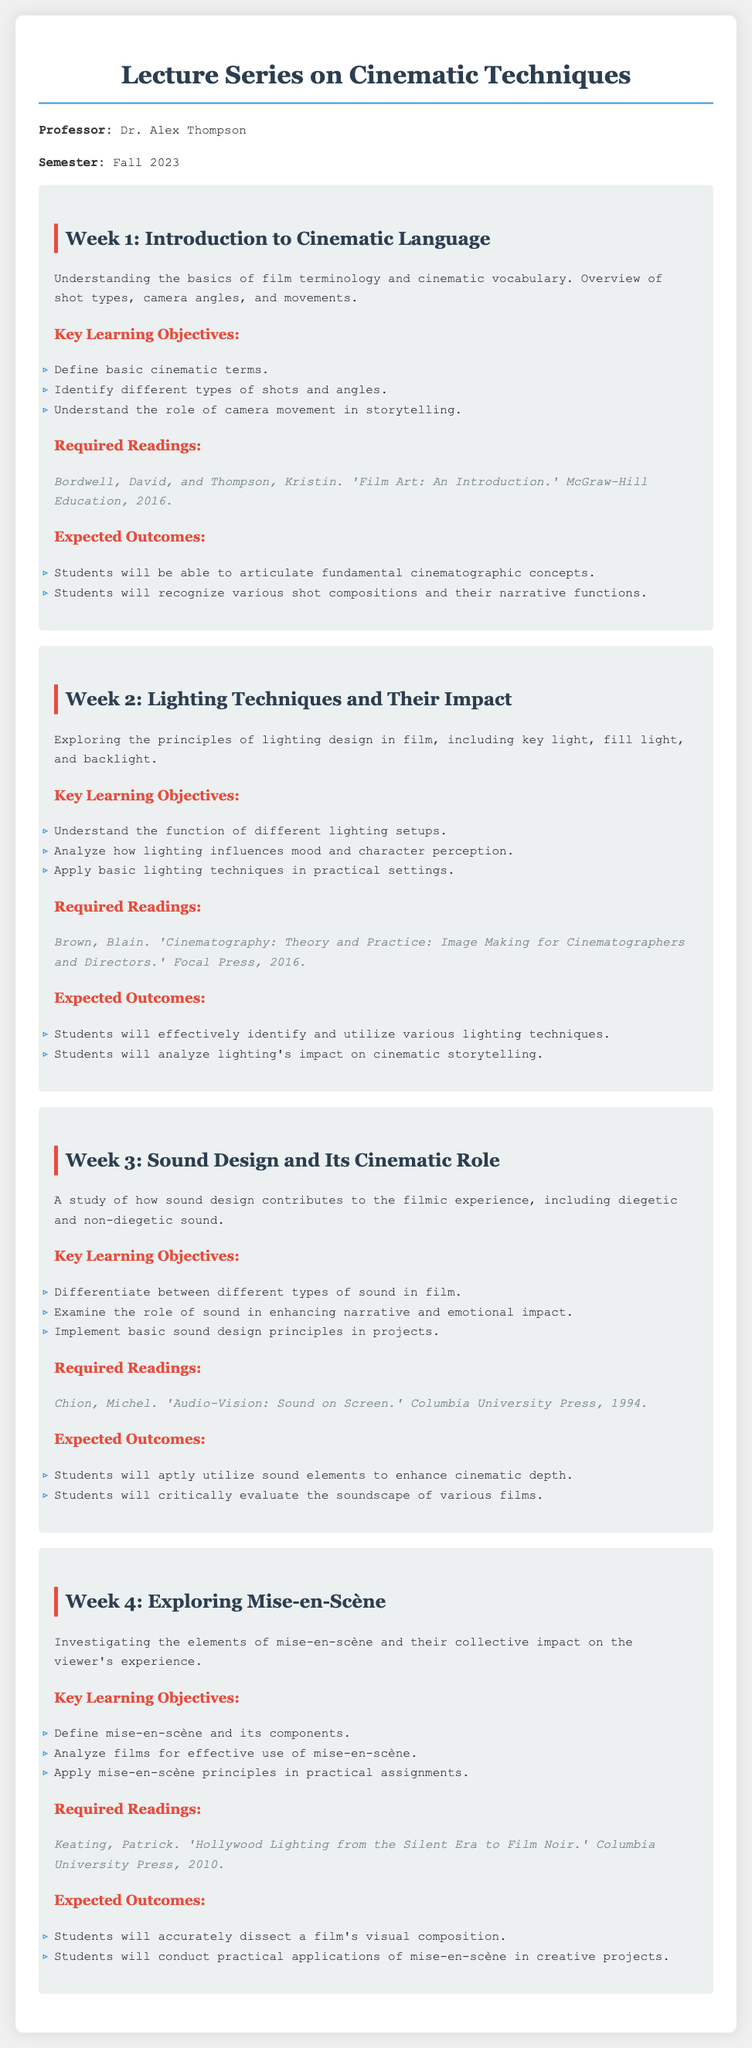What is the title of the lecture series? The title of the lecture series is presented at the beginning of the document, specifically listed as "Lecture Series on Cinematic Techniques."
Answer: Lecture Series on Cinematic Techniques Who is the professor for the series? The professor's name is mentioned in the introductory part of the document, specifying Dr. Alex Thompson.
Answer: Dr. Alex Thompson What is the required reading for Week 1? The document lists the required reading for Week 1, which is "Film Art: An Introduction."
Answer: Film Art: An Introduction How many lectures are outlined in the document? By counting the number of lecture sections provided, it is determined that there are four lectures.
Answer: 4 What is a key learning objective of Week 3? The key learning objectives for Week 3 include differentiating between different types of sound in film.
Answer: Differentiate between different types of sound in film What is a theme explored in Week 2? The theme explored in Week 2 focuses on lighting techniques and their impact in film.
Answer: Lighting techniques and their impact Which week is dedicated to exploring mise-en-scène? The document specifies Week 4 as the week dedicated to the study of mise-en-scène.
Answer: Week 4 What type of source is the reading for Week 4? The reading for Week 4, by Patrick Keating, is a book published by Columbia University Press.
Answer: Book What will students do in practical assignments? The expected outcomes section indicates students will apply mise-en-scène principles in practical assignments.
Answer: Apply mise-en-scène principles in practical assignments 